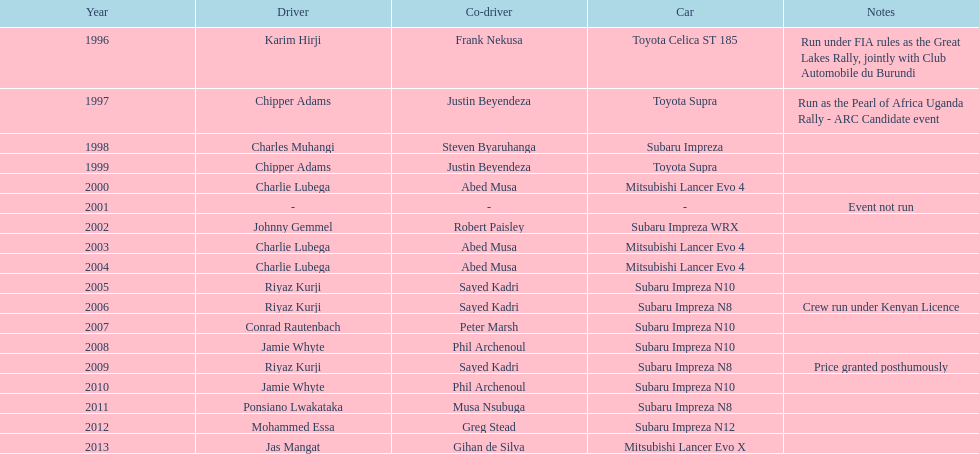How many times has the successful driver been behind the wheel of a toyota supra? 2. 